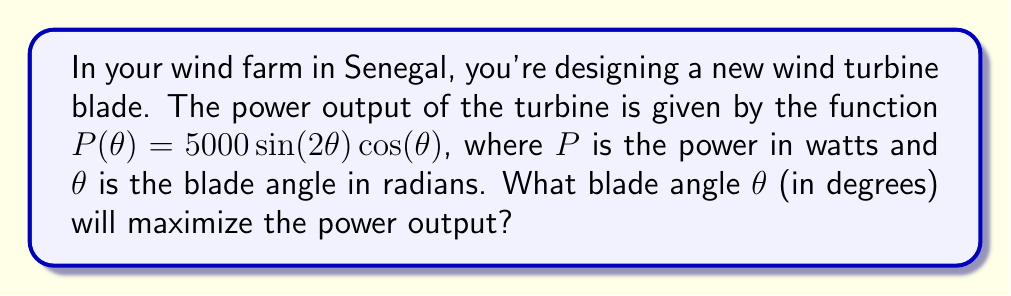Give your solution to this math problem. To find the optimal angle, we need to maximize the function $P(\theta)$. Let's follow these steps:

1) First, we need to find the derivative of $P(\theta)$:
   $$\frac{d}{d\theta}P(\theta) = 5000[\cos(2\theta)\cos(\theta) + \sin(2\theta)(-\sin(\theta))]$$
   $$= 5000[\cos(2\theta)\cos(\theta) - 2\sin(\theta)\cos(\theta)\sin(\theta)]$$
   $$= 5000\cos(\theta)[\cos(2\theta) - 2\sin^2(\theta)]$$

2) For maximum power, set the derivative to zero:
   $$5000\cos(\theta)[\cos(2\theta) - 2\sin^2(\theta)] = 0$$

3) This equation is satisfied when either $\cos(\theta) = 0$ or $\cos(2\theta) - 2\sin^2(\theta) = 0$

4) If $\cos(\theta) = 0$, then $\theta = \frac{\pi}{2}$ or $\frac{3\pi}{2}$, but these give $P(\theta) = 0$, so they're minima.

5) Let's solve $\cos(2\theta) - 2\sin^2(\theta) = 0$:
   $$\cos^2(\theta) - \sin^2(\theta) - 2\sin^2(\theta) = 0$$
   $$\cos^2(\theta) - 3\sin^2(\theta) = 0$$
   $$\cos^2(\theta) = 3\sin^2(\theta)$$
   $$\cot^2(\theta) = 3$$
   $$\cot(\theta) = \sqrt{3}$$
   $$\theta = \arctan(\frac{1}{\sqrt{3}})$$

6) This gives us $\theta \approx 0.5236$ radians

7) Converting to degrees: $0.5236 \times \frac{180}{\pi} \approx 30°$

8) To confirm this is a maximum, we could check the second derivative is negative at this point.
Answer: 30° 